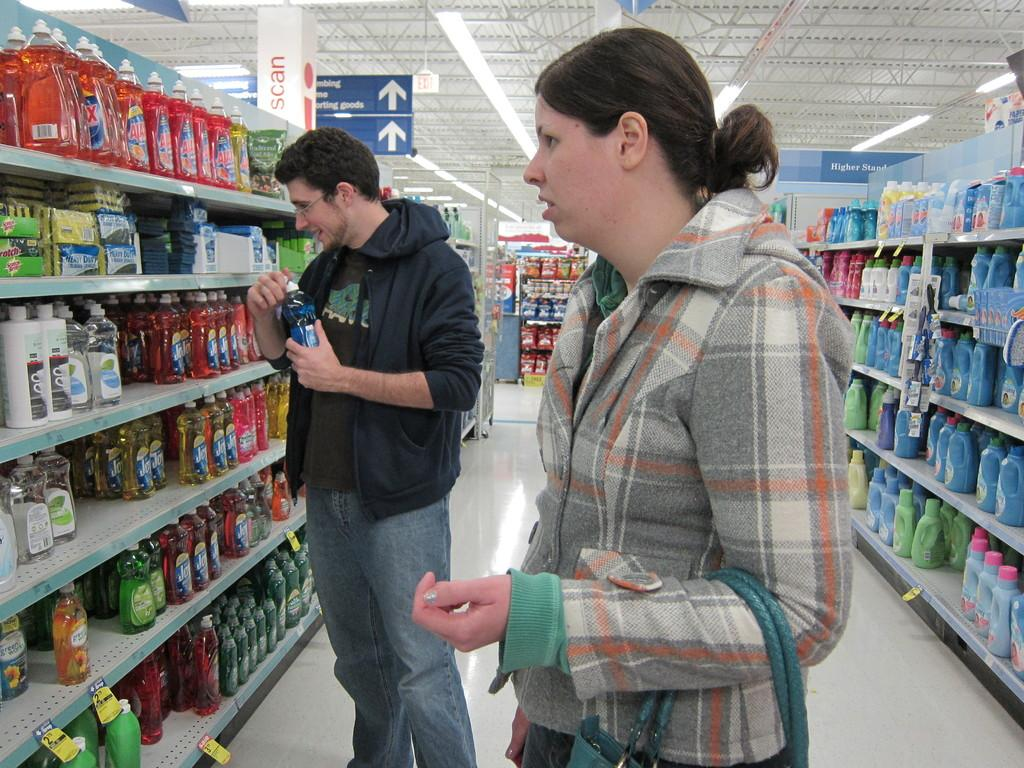<image>
Relay a brief, clear account of the picture shown. Laundry Isle of a store with two people shopping, that are looking at Ajax and Joy. 